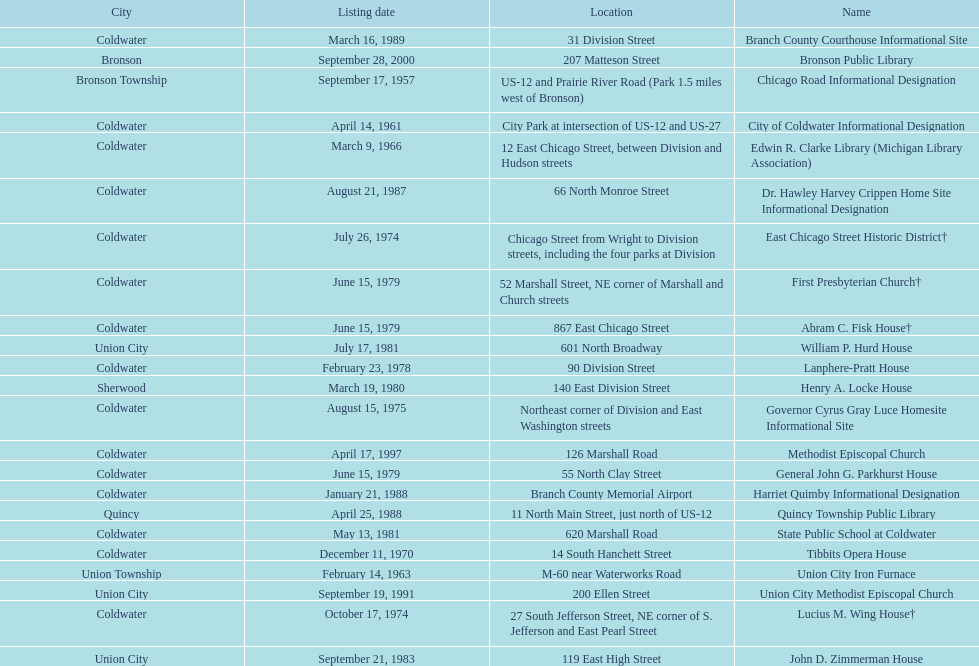How many historic sites are listed in coldwater? 15. 